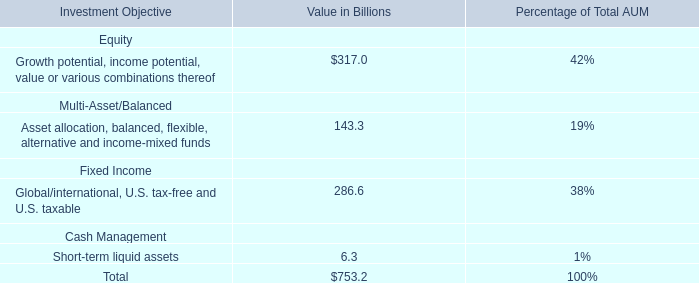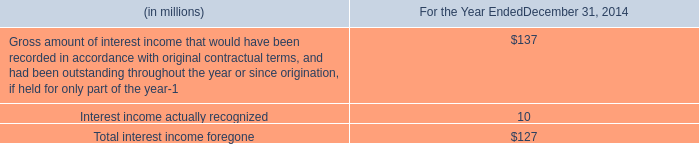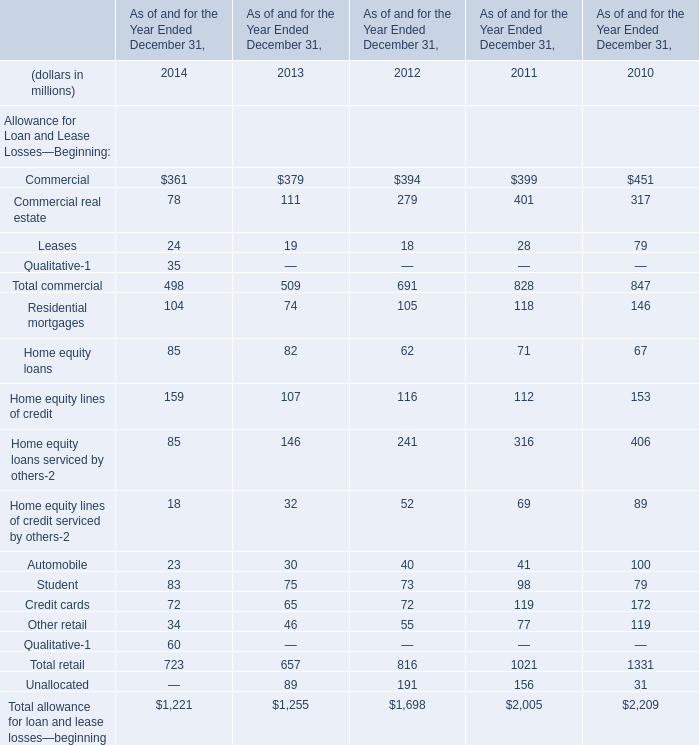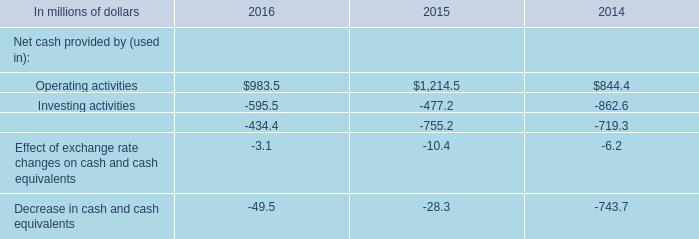In the year / section with largest amount of Commercial real estate , what's the sum of Allowance for Loan and Lease Losses—Beginning? (in million) 
Computations: ((399 + 401) + 28)
Answer: 828.0. 